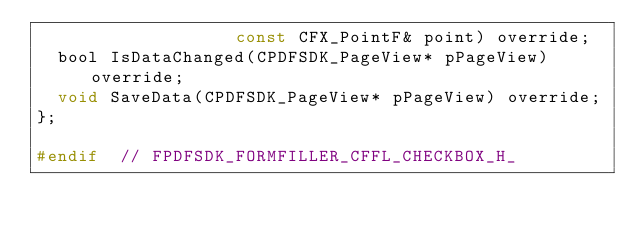<code> <loc_0><loc_0><loc_500><loc_500><_C_>                   const CFX_PointF& point) override;
  bool IsDataChanged(CPDFSDK_PageView* pPageView) override;
  void SaveData(CPDFSDK_PageView* pPageView) override;
};

#endif  // FPDFSDK_FORMFILLER_CFFL_CHECKBOX_H_
</code> 